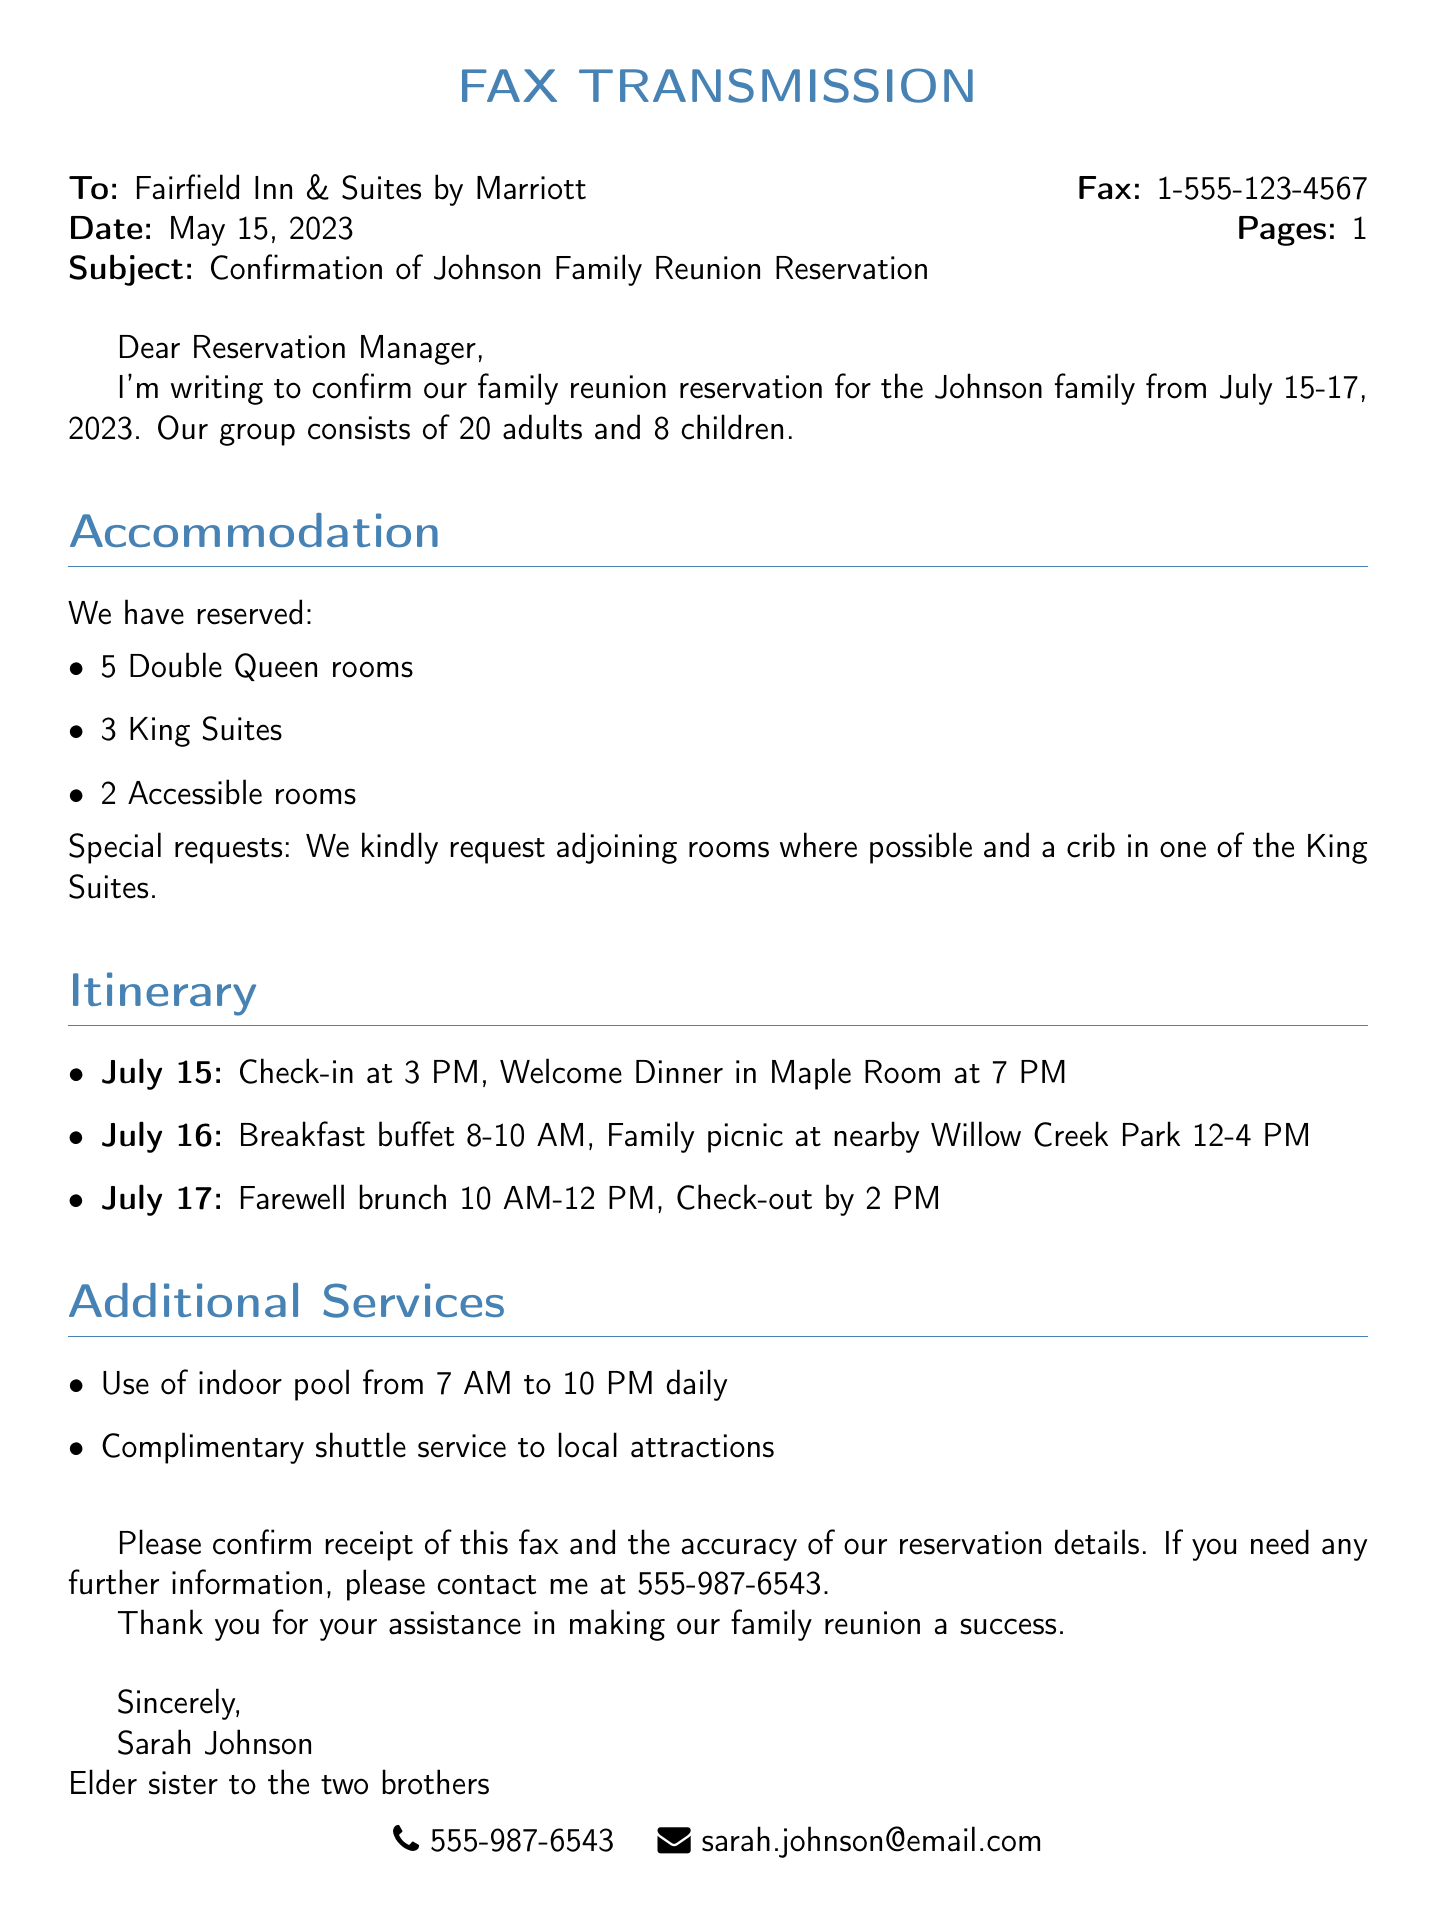What are the dates of the reunion? The dates for the family reunion mentioned in the document are July 15-17, 2023.
Answer: July 15-17, 2023 How many adults are in the group? The document states that the group consists of 20 adults.
Answer: 20 adults What special request was made for the rooms? The document mentions that a crib was requested in one of the King Suites.
Answer: A crib What time is the check-out on July 17? The check-out time specified in the document is by 2 PM.
Answer: 2 PM How many King Suites are reserved? According to the document, there are 3 King Suites reserved.
Answer: 3 King Suites What is the name of the park where the family picnic will take place? The picnic is scheduled to be at Willow Creek Park, as stated in the document.
Answer: Willow Creek Park What is the purpose of the fax? The purpose of the fax is to confirm the family reunion reservation details.
Answer: Confirm reservation What is the contact information for Sarah Johnson? Sarah Johnson's contact information listed includes a phone number and email address.
Answer: 555-987-6543, sarah.johnson@email.com What type of document is this? The document is a fax transmission regarding a family reunion reservation.
Answer: Fax transmission 